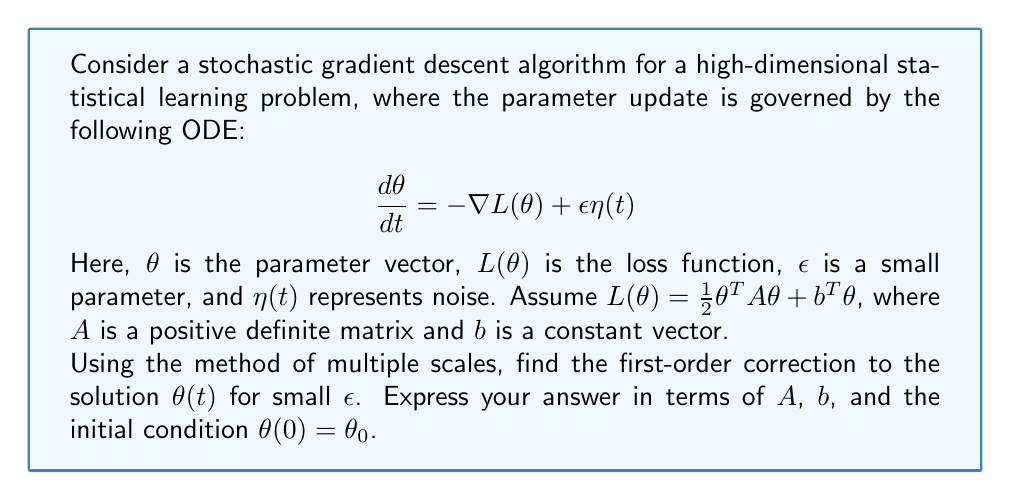Give your solution to this math problem. To solve this problem using the method of multiple scales, we follow these steps:

1) Introduce two time scales: $t_0 = t$ and $t_1 = \epsilon t$.

2) Assume a solution of the form:
   $$\theta(t) = \theta^{(0)}(t_0, t_1) + \epsilon \theta^{(1)}(t_0, t_1) + O(\epsilon^2)$$

3) Express the time derivative in terms of the two scales:
   $$\frac{d}{dt} = \frac{\partial}{\partial t_0} + \epsilon \frac{\partial}{\partial t_1}$$

4) Substitute these into the original ODE:
   $$(\frac{\partial}{\partial t_0} + \epsilon \frac{\partial}{\partial t_1})(\theta^{(0)} + \epsilon \theta^{(1)}) = -A(\theta^{(0)} + \epsilon \theta^{(1)}) - b + \epsilon \eta(t_0)$$

5) Collect terms of order $\epsilon^0$ and $\epsilon^1$:

   $O(\epsilon^0)$: $\frac{\partial \theta^{(0)}}{\partial t_0} = -A\theta^{(0)} - b$
   
   $O(\epsilon^1)$: $\frac{\partial \theta^{(0)}}{\partial t_1} + \frac{\partial \theta^{(1)}}{\partial t_0} = -A\theta^{(1)} + \eta(t_0)$

6) Solve the $O(\epsilon^0)$ equation:
   $$\theta^{(0)}(t_0, t_1) = e^{-At_0}(\theta_0 + A^{-1}b) - A^{-1}b$$

7) Substitute this into the $O(\epsilon^1)$ equation:
   $$\frac{\partial \theta^{(1)}}{\partial t_0} + A\theta^{(1)} = -\frac{\partial \theta^{(0)}}{\partial t_1} + \eta(t_0)$$

8) The solution to this equation involves a secular term that grows with $t_0$. To eliminate this, we set:
   $$\frac{\partial \theta^{(0)}}{\partial t_1} = 0$$

9) Solve the remaining equation for $\theta^{(1)}$:
   $$\theta^{(1)}(t_0, t_1) = \int_0^{t_0} e^{-A(t_0-s)}\eta(s)ds$$

10) Combine the results to get the first-order correction:
    $$\theta(t) \approx e^{-At}(\theta_0 + A^{-1}b) - A^{-1}b + \epsilon \int_0^t e^{-A(t-s)}\eta(s)ds$$
Answer: $\theta(t) \approx e^{-At}(\theta_0 + A^{-1}b) - A^{-1}b + \epsilon \int_0^t e^{-A(t-s)}\eta(s)ds$ 